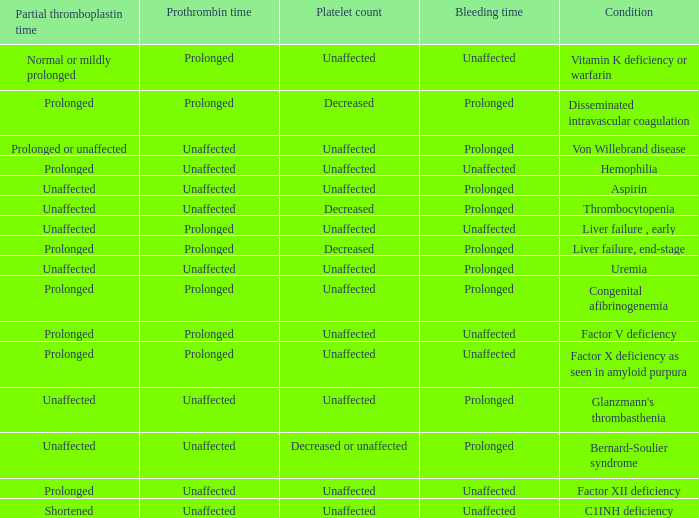Which Condition has a Bleeding time of unaffected, and a Partial thromboplastin time of prolonged, and a Prothrombin time of unaffected? Hemophilia, Factor XII deficiency. 